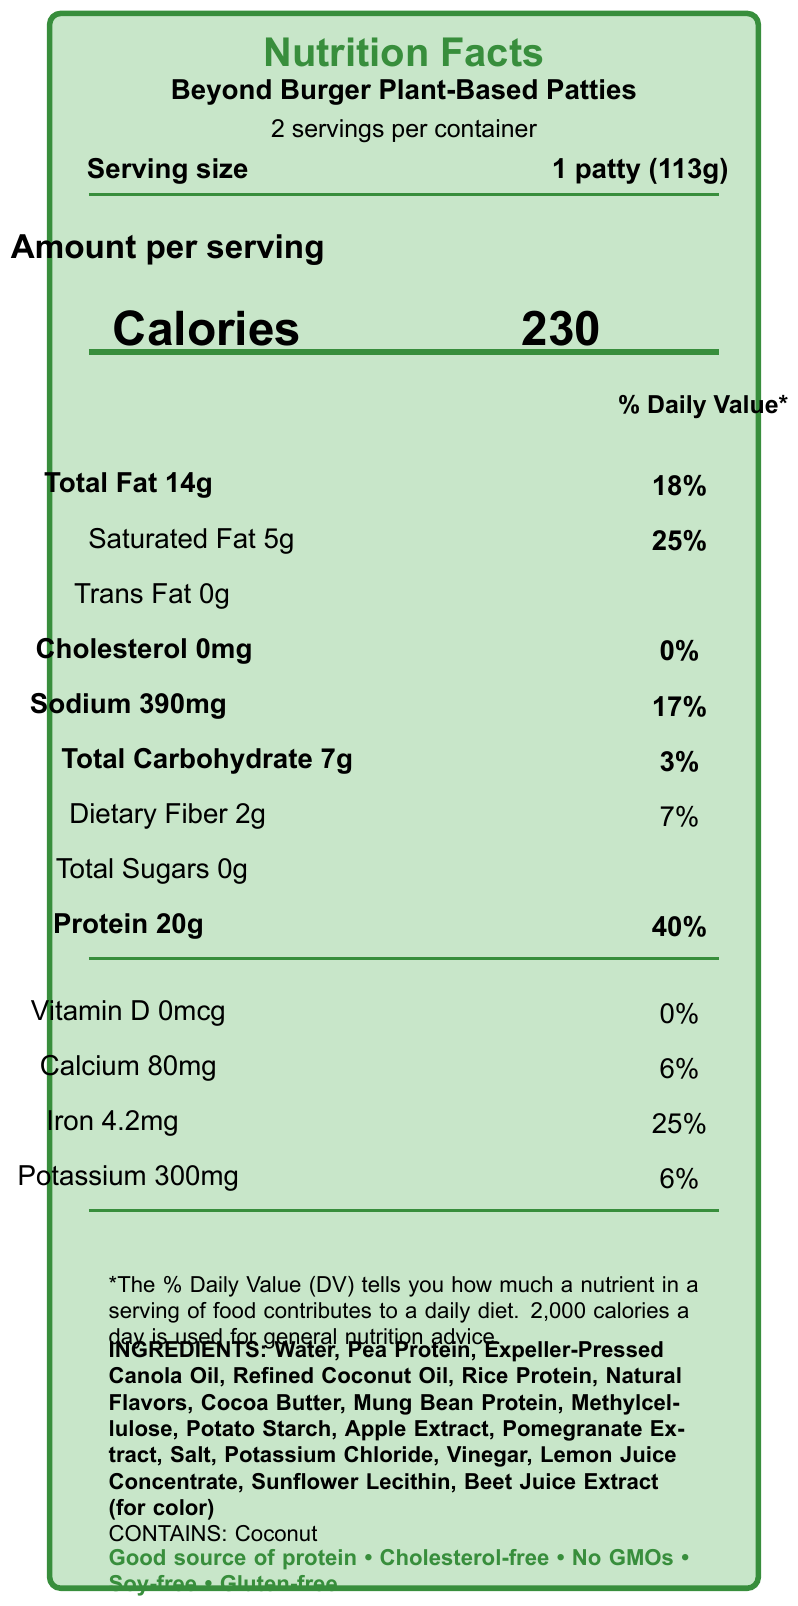what is the serving size? The serving size is listed as 1 patty, which weighs 113 grams.
Answer: 1 patty (113g) how many calories are in a single serving? The calories per serving are shown as 230 on the document.
Answer: 230 what is the percentage of daily value for saturated fat? The saturated fat daily value percentage is listed next to the saturated fat amount in the document.
Answer: 25% does the product contain any trans fat? The trans fat content is listed as 0g, indicating there is no trans fat in the product.
Answer: No what are the main protein sources in the ingredients? These protein sources are listed in the ingredients section on the document.
Answer: Pea Protein, Rice Protein, Mung Bean Protein what is the total carbohydrate amount per serving? A. 10g B. 5g C. 7g D. 14g The total carbohydrate amount per serving is listed as 7g in the document.
Answer: C which of the following nutrients does the patty provide the highest daily value percentage? A. Sodium B. Calcium C. Iron D. Protein Protein has the highest daily value percentage listed as 40%.
Answer: D is the product cholesterol-free? The document states the product has 0mg of cholesterol and also claims it is cholesterol-free.
Answer: Yes summarize the main idea of the document. The document summarizes the nutritional breakdown, ingredients, health claims, and comparison to traditional beef, offering insights into the product's dietary benefits and eco-friendly considerations.
Answer: This Nutrition Facts Label provides the nutritional content and ingredient information for Beyond Burger Plant-Based Patties. It highlights the product's protein content, reduced saturated fats, cholesterol-free status, and absence of GMOs, soy, and gluten. It compares favorably to 80/20 ground beef with comparable protein, less saturated fat, and no cholesterol. what is the percentage of daily value for dietary fiber? The dietary fiber daily value percentage is listed next to the dietary fiber amount in the document.
Answer: 7% how much iron does one serving of the Beyond Burger contain? The amount of iron per serving is listed as 4.2mg in the document.
Answer: 4.2mg how many servings are there per container? The serving information at the top section of the document states there are 2 servings per container.
Answer: 2 servings does the product contain any GMO ingredients? The document explicitly states "No GMOs" under the health claims section.
Answer: No what are the potential tax implications for this product? The tax implications section at the bottom of the document provides details on potential tax benefits for medical expenses, business expenses in the food industry, and eco-friendly tax credits.
Answer: May be eligible for medical expense deduction if prescribed by a doctor, could be a deductible business expense for food industry professionals, may be eligible for eco-friendly tax credits in some jurisdictions. what flavoring ingredients are listed? These flavoring ingredients are listed in the ingredients section on the document.
Answer: Natural Flavors, Apple Extract, Pomegranate Extract, Lemon Juice Concentrate how much potassium is in one serving? The potassium amount is listed as 300mg in the document.
Answer: 300mg is this product soy-free? The document lists "Soy-free" as one of the health claims.
Answer: Yes what is the sodium content per serving? The sodium content per serving is listed as 390mg in the document.
Answer: 390mg does this product contain any gluten? The document states it is gluten-free under the health claims section.
Answer: No how much energy does one serving provide compared to a 2,000 calorie daily diet? One serving provides 230 calories, which is 11.5% of a 2,000 calorie daily diet (calculated as 230/2000 * 100).
Answer: 11.5% what is the source of color in the product? The ingredients list includes Beet Juice Extract for color.
Answer: Beet Juice Extract which vitamin has the lowest percentage of daily value? Vitamin D has a 0% daily value listed in the document.
Answer: Vitamin D how much total fat does one serving contain? The total fat content per serving is listed as 14g in the document.
Answer: 14g what are the health claims made about this product? The health claims are listed at the bottom of the document.
Answer: Good source of protein, cholesterol-free, no GMOs, soy-free, gluten-free 